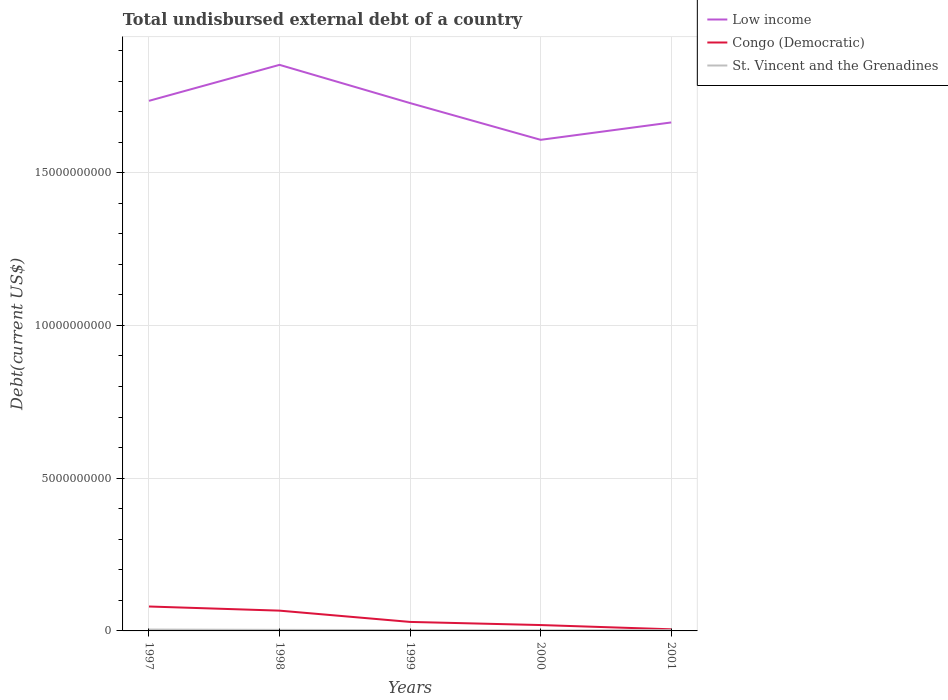Does the line corresponding to St. Vincent and the Grenadines intersect with the line corresponding to Low income?
Give a very brief answer. No. Is the number of lines equal to the number of legend labels?
Offer a terse response. Yes. Across all years, what is the maximum total undisbursed external debt in Congo (Democratic)?
Offer a very short reply. 5.33e+07. What is the total total undisbursed external debt in Congo (Democratic) in the graph?
Make the answer very short. 3.69e+08. What is the difference between the highest and the second highest total undisbursed external debt in Low income?
Offer a terse response. 2.45e+09. What is the difference between the highest and the lowest total undisbursed external debt in St. Vincent and the Grenadines?
Make the answer very short. 2. Is the total undisbursed external debt in Low income strictly greater than the total undisbursed external debt in Congo (Democratic) over the years?
Provide a succinct answer. No. How many lines are there?
Your response must be concise. 3. How many years are there in the graph?
Ensure brevity in your answer.  5. Does the graph contain grids?
Provide a succinct answer. Yes. Where does the legend appear in the graph?
Offer a terse response. Top right. How many legend labels are there?
Provide a succinct answer. 3. What is the title of the graph?
Make the answer very short. Total undisbursed external debt of a country. Does "Albania" appear as one of the legend labels in the graph?
Keep it short and to the point. No. What is the label or title of the X-axis?
Offer a very short reply. Years. What is the label or title of the Y-axis?
Provide a short and direct response. Debt(current US$). What is the Debt(current US$) of Low income in 1997?
Give a very brief answer. 1.74e+1. What is the Debt(current US$) of Congo (Democratic) in 1997?
Make the answer very short. 8.00e+08. What is the Debt(current US$) in St. Vincent and the Grenadines in 1997?
Make the answer very short. 4.47e+07. What is the Debt(current US$) in Low income in 1998?
Give a very brief answer. 1.85e+1. What is the Debt(current US$) of Congo (Democratic) in 1998?
Offer a terse response. 6.64e+08. What is the Debt(current US$) of St. Vincent and the Grenadines in 1998?
Your answer should be compact. 3.41e+07. What is the Debt(current US$) of Low income in 1999?
Your answer should be very brief. 1.73e+1. What is the Debt(current US$) of Congo (Democratic) in 1999?
Your response must be concise. 2.95e+08. What is the Debt(current US$) in St. Vincent and the Grenadines in 1999?
Provide a succinct answer. 2.66e+07. What is the Debt(current US$) of Low income in 2000?
Your answer should be very brief. 1.61e+1. What is the Debt(current US$) in Congo (Democratic) in 2000?
Offer a terse response. 1.92e+08. What is the Debt(current US$) of St. Vincent and the Grenadines in 2000?
Make the answer very short. 1.90e+07. What is the Debt(current US$) in Low income in 2001?
Make the answer very short. 1.66e+1. What is the Debt(current US$) of Congo (Democratic) in 2001?
Give a very brief answer. 5.33e+07. What is the Debt(current US$) of St. Vincent and the Grenadines in 2001?
Offer a very short reply. 2.50e+07. Across all years, what is the maximum Debt(current US$) in Low income?
Ensure brevity in your answer.  1.85e+1. Across all years, what is the maximum Debt(current US$) in Congo (Democratic)?
Your answer should be very brief. 8.00e+08. Across all years, what is the maximum Debt(current US$) of St. Vincent and the Grenadines?
Provide a succinct answer. 4.47e+07. Across all years, what is the minimum Debt(current US$) in Low income?
Give a very brief answer. 1.61e+1. Across all years, what is the minimum Debt(current US$) in Congo (Democratic)?
Your response must be concise. 5.33e+07. Across all years, what is the minimum Debt(current US$) in St. Vincent and the Grenadines?
Your response must be concise. 1.90e+07. What is the total Debt(current US$) in Low income in the graph?
Offer a very short reply. 8.59e+1. What is the total Debt(current US$) of Congo (Democratic) in the graph?
Make the answer very short. 2.00e+09. What is the total Debt(current US$) in St. Vincent and the Grenadines in the graph?
Your response must be concise. 1.49e+08. What is the difference between the Debt(current US$) in Low income in 1997 and that in 1998?
Make the answer very short. -1.18e+09. What is the difference between the Debt(current US$) in Congo (Democratic) in 1997 and that in 1998?
Your answer should be compact. 1.36e+08. What is the difference between the Debt(current US$) in St. Vincent and the Grenadines in 1997 and that in 1998?
Provide a succinct answer. 1.05e+07. What is the difference between the Debt(current US$) in Low income in 1997 and that in 1999?
Your answer should be very brief. 7.38e+07. What is the difference between the Debt(current US$) of Congo (Democratic) in 1997 and that in 1999?
Provide a short and direct response. 5.05e+08. What is the difference between the Debt(current US$) of St. Vincent and the Grenadines in 1997 and that in 1999?
Offer a terse response. 1.80e+07. What is the difference between the Debt(current US$) of Low income in 1997 and that in 2000?
Keep it short and to the point. 1.28e+09. What is the difference between the Debt(current US$) of Congo (Democratic) in 1997 and that in 2000?
Your response must be concise. 6.07e+08. What is the difference between the Debt(current US$) in St. Vincent and the Grenadines in 1997 and that in 2000?
Your answer should be compact. 2.57e+07. What is the difference between the Debt(current US$) in Low income in 1997 and that in 2001?
Make the answer very short. 7.07e+08. What is the difference between the Debt(current US$) of Congo (Democratic) in 1997 and that in 2001?
Offer a terse response. 7.46e+08. What is the difference between the Debt(current US$) in St. Vincent and the Grenadines in 1997 and that in 2001?
Your answer should be compact. 1.97e+07. What is the difference between the Debt(current US$) of Low income in 1998 and that in 1999?
Offer a terse response. 1.25e+09. What is the difference between the Debt(current US$) of Congo (Democratic) in 1998 and that in 1999?
Keep it short and to the point. 3.69e+08. What is the difference between the Debt(current US$) of St. Vincent and the Grenadines in 1998 and that in 1999?
Keep it short and to the point. 7.50e+06. What is the difference between the Debt(current US$) of Low income in 1998 and that in 2000?
Offer a very short reply. 2.45e+09. What is the difference between the Debt(current US$) of Congo (Democratic) in 1998 and that in 2000?
Ensure brevity in your answer.  4.72e+08. What is the difference between the Debt(current US$) of St. Vincent and the Grenadines in 1998 and that in 2000?
Offer a very short reply. 1.52e+07. What is the difference between the Debt(current US$) of Low income in 1998 and that in 2001?
Make the answer very short. 1.89e+09. What is the difference between the Debt(current US$) of Congo (Democratic) in 1998 and that in 2001?
Your response must be concise. 6.10e+08. What is the difference between the Debt(current US$) in St. Vincent and the Grenadines in 1998 and that in 2001?
Offer a very short reply. 9.16e+06. What is the difference between the Debt(current US$) of Low income in 1999 and that in 2000?
Provide a short and direct response. 1.20e+09. What is the difference between the Debt(current US$) of Congo (Democratic) in 1999 and that in 2000?
Provide a short and direct response. 1.03e+08. What is the difference between the Debt(current US$) in St. Vincent and the Grenadines in 1999 and that in 2000?
Your answer should be compact. 7.69e+06. What is the difference between the Debt(current US$) of Low income in 1999 and that in 2001?
Offer a terse response. 6.34e+08. What is the difference between the Debt(current US$) in Congo (Democratic) in 1999 and that in 2001?
Give a very brief answer. 2.41e+08. What is the difference between the Debt(current US$) in St. Vincent and the Grenadines in 1999 and that in 2001?
Your answer should be very brief. 1.66e+06. What is the difference between the Debt(current US$) of Low income in 2000 and that in 2001?
Give a very brief answer. -5.69e+08. What is the difference between the Debt(current US$) in Congo (Democratic) in 2000 and that in 2001?
Your answer should be compact. 1.39e+08. What is the difference between the Debt(current US$) in St. Vincent and the Grenadines in 2000 and that in 2001?
Make the answer very short. -6.02e+06. What is the difference between the Debt(current US$) in Low income in 1997 and the Debt(current US$) in Congo (Democratic) in 1998?
Your answer should be compact. 1.67e+1. What is the difference between the Debt(current US$) of Low income in 1997 and the Debt(current US$) of St. Vincent and the Grenadines in 1998?
Ensure brevity in your answer.  1.73e+1. What is the difference between the Debt(current US$) in Congo (Democratic) in 1997 and the Debt(current US$) in St. Vincent and the Grenadines in 1998?
Offer a very short reply. 7.65e+08. What is the difference between the Debt(current US$) in Low income in 1997 and the Debt(current US$) in Congo (Democratic) in 1999?
Your answer should be very brief. 1.71e+1. What is the difference between the Debt(current US$) in Low income in 1997 and the Debt(current US$) in St. Vincent and the Grenadines in 1999?
Offer a terse response. 1.73e+1. What is the difference between the Debt(current US$) in Congo (Democratic) in 1997 and the Debt(current US$) in St. Vincent and the Grenadines in 1999?
Provide a short and direct response. 7.73e+08. What is the difference between the Debt(current US$) of Low income in 1997 and the Debt(current US$) of Congo (Democratic) in 2000?
Make the answer very short. 1.72e+1. What is the difference between the Debt(current US$) of Low income in 1997 and the Debt(current US$) of St. Vincent and the Grenadines in 2000?
Provide a succinct answer. 1.73e+1. What is the difference between the Debt(current US$) of Congo (Democratic) in 1997 and the Debt(current US$) of St. Vincent and the Grenadines in 2000?
Keep it short and to the point. 7.81e+08. What is the difference between the Debt(current US$) in Low income in 1997 and the Debt(current US$) in Congo (Democratic) in 2001?
Your answer should be very brief. 1.73e+1. What is the difference between the Debt(current US$) of Low income in 1997 and the Debt(current US$) of St. Vincent and the Grenadines in 2001?
Provide a succinct answer. 1.73e+1. What is the difference between the Debt(current US$) of Congo (Democratic) in 1997 and the Debt(current US$) of St. Vincent and the Grenadines in 2001?
Offer a very short reply. 7.75e+08. What is the difference between the Debt(current US$) of Low income in 1998 and the Debt(current US$) of Congo (Democratic) in 1999?
Your answer should be compact. 1.82e+1. What is the difference between the Debt(current US$) of Low income in 1998 and the Debt(current US$) of St. Vincent and the Grenadines in 1999?
Provide a succinct answer. 1.85e+1. What is the difference between the Debt(current US$) of Congo (Democratic) in 1998 and the Debt(current US$) of St. Vincent and the Grenadines in 1999?
Ensure brevity in your answer.  6.37e+08. What is the difference between the Debt(current US$) in Low income in 1998 and the Debt(current US$) in Congo (Democratic) in 2000?
Offer a terse response. 1.83e+1. What is the difference between the Debt(current US$) in Low income in 1998 and the Debt(current US$) in St. Vincent and the Grenadines in 2000?
Your answer should be very brief. 1.85e+1. What is the difference between the Debt(current US$) of Congo (Democratic) in 1998 and the Debt(current US$) of St. Vincent and the Grenadines in 2000?
Offer a very short reply. 6.45e+08. What is the difference between the Debt(current US$) of Low income in 1998 and the Debt(current US$) of Congo (Democratic) in 2001?
Provide a succinct answer. 1.85e+1. What is the difference between the Debt(current US$) of Low income in 1998 and the Debt(current US$) of St. Vincent and the Grenadines in 2001?
Your answer should be compact. 1.85e+1. What is the difference between the Debt(current US$) in Congo (Democratic) in 1998 and the Debt(current US$) in St. Vincent and the Grenadines in 2001?
Keep it short and to the point. 6.39e+08. What is the difference between the Debt(current US$) of Low income in 1999 and the Debt(current US$) of Congo (Democratic) in 2000?
Make the answer very short. 1.71e+1. What is the difference between the Debt(current US$) of Low income in 1999 and the Debt(current US$) of St. Vincent and the Grenadines in 2000?
Give a very brief answer. 1.73e+1. What is the difference between the Debt(current US$) in Congo (Democratic) in 1999 and the Debt(current US$) in St. Vincent and the Grenadines in 2000?
Ensure brevity in your answer.  2.76e+08. What is the difference between the Debt(current US$) of Low income in 1999 and the Debt(current US$) of Congo (Democratic) in 2001?
Give a very brief answer. 1.72e+1. What is the difference between the Debt(current US$) in Low income in 1999 and the Debt(current US$) in St. Vincent and the Grenadines in 2001?
Your answer should be compact. 1.73e+1. What is the difference between the Debt(current US$) in Congo (Democratic) in 1999 and the Debt(current US$) in St. Vincent and the Grenadines in 2001?
Your response must be concise. 2.70e+08. What is the difference between the Debt(current US$) in Low income in 2000 and the Debt(current US$) in Congo (Democratic) in 2001?
Your answer should be compact. 1.60e+1. What is the difference between the Debt(current US$) of Low income in 2000 and the Debt(current US$) of St. Vincent and the Grenadines in 2001?
Ensure brevity in your answer.  1.60e+1. What is the difference between the Debt(current US$) of Congo (Democratic) in 2000 and the Debt(current US$) of St. Vincent and the Grenadines in 2001?
Your response must be concise. 1.67e+08. What is the average Debt(current US$) in Low income per year?
Provide a succinct answer. 1.72e+1. What is the average Debt(current US$) in Congo (Democratic) per year?
Keep it short and to the point. 4.01e+08. What is the average Debt(current US$) in St. Vincent and the Grenadines per year?
Offer a terse response. 2.99e+07. In the year 1997, what is the difference between the Debt(current US$) of Low income and Debt(current US$) of Congo (Democratic)?
Make the answer very short. 1.66e+1. In the year 1997, what is the difference between the Debt(current US$) of Low income and Debt(current US$) of St. Vincent and the Grenadines?
Provide a short and direct response. 1.73e+1. In the year 1997, what is the difference between the Debt(current US$) of Congo (Democratic) and Debt(current US$) of St. Vincent and the Grenadines?
Your response must be concise. 7.55e+08. In the year 1998, what is the difference between the Debt(current US$) in Low income and Debt(current US$) in Congo (Democratic)?
Your response must be concise. 1.79e+1. In the year 1998, what is the difference between the Debt(current US$) of Low income and Debt(current US$) of St. Vincent and the Grenadines?
Give a very brief answer. 1.85e+1. In the year 1998, what is the difference between the Debt(current US$) of Congo (Democratic) and Debt(current US$) of St. Vincent and the Grenadines?
Provide a short and direct response. 6.30e+08. In the year 1999, what is the difference between the Debt(current US$) in Low income and Debt(current US$) in Congo (Democratic)?
Keep it short and to the point. 1.70e+1. In the year 1999, what is the difference between the Debt(current US$) of Low income and Debt(current US$) of St. Vincent and the Grenadines?
Offer a very short reply. 1.73e+1. In the year 1999, what is the difference between the Debt(current US$) of Congo (Democratic) and Debt(current US$) of St. Vincent and the Grenadines?
Offer a very short reply. 2.68e+08. In the year 2000, what is the difference between the Debt(current US$) of Low income and Debt(current US$) of Congo (Democratic)?
Your response must be concise. 1.59e+1. In the year 2000, what is the difference between the Debt(current US$) in Low income and Debt(current US$) in St. Vincent and the Grenadines?
Keep it short and to the point. 1.61e+1. In the year 2000, what is the difference between the Debt(current US$) of Congo (Democratic) and Debt(current US$) of St. Vincent and the Grenadines?
Keep it short and to the point. 1.73e+08. In the year 2001, what is the difference between the Debt(current US$) of Low income and Debt(current US$) of Congo (Democratic)?
Your response must be concise. 1.66e+1. In the year 2001, what is the difference between the Debt(current US$) in Low income and Debt(current US$) in St. Vincent and the Grenadines?
Provide a succinct answer. 1.66e+1. In the year 2001, what is the difference between the Debt(current US$) in Congo (Democratic) and Debt(current US$) in St. Vincent and the Grenadines?
Keep it short and to the point. 2.83e+07. What is the ratio of the Debt(current US$) in Low income in 1997 to that in 1998?
Your response must be concise. 0.94. What is the ratio of the Debt(current US$) of Congo (Democratic) in 1997 to that in 1998?
Make the answer very short. 1.2. What is the ratio of the Debt(current US$) in St. Vincent and the Grenadines in 1997 to that in 1998?
Provide a succinct answer. 1.31. What is the ratio of the Debt(current US$) in Low income in 1997 to that in 1999?
Keep it short and to the point. 1. What is the ratio of the Debt(current US$) in Congo (Democratic) in 1997 to that in 1999?
Keep it short and to the point. 2.71. What is the ratio of the Debt(current US$) in St. Vincent and the Grenadines in 1997 to that in 1999?
Offer a terse response. 1.68. What is the ratio of the Debt(current US$) of Low income in 1997 to that in 2000?
Give a very brief answer. 1.08. What is the ratio of the Debt(current US$) in Congo (Democratic) in 1997 to that in 2000?
Your answer should be very brief. 4.16. What is the ratio of the Debt(current US$) of St. Vincent and the Grenadines in 1997 to that in 2000?
Your answer should be very brief. 2.36. What is the ratio of the Debt(current US$) of Low income in 1997 to that in 2001?
Give a very brief answer. 1.04. What is the ratio of the Debt(current US$) of Congo (Democratic) in 1997 to that in 2001?
Your answer should be very brief. 15. What is the ratio of the Debt(current US$) of St. Vincent and the Grenadines in 1997 to that in 2001?
Provide a short and direct response. 1.79. What is the ratio of the Debt(current US$) of Low income in 1998 to that in 1999?
Your answer should be very brief. 1.07. What is the ratio of the Debt(current US$) in Congo (Democratic) in 1998 to that in 1999?
Make the answer very short. 2.25. What is the ratio of the Debt(current US$) in St. Vincent and the Grenadines in 1998 to that in 1999?
Make the answer very short. 1.28. What is the ratio of the Debt(current US$) in Low income in 1998 to that in 2000?
Offer a very short reply. 1.15. What is the ratio of the Debt(current US$) of Congo (Democratic) in 1998 to that in 2000?
Your response must be concise. 3.46. What is the ratio of the Debt(current US$) of St. Vincent and the Grenadines in 1998 to that in 2000?
Give a very brief answer. 1.8. What is the ratio of the Debt(current US$) in Low income in 1998 to that in 2001?
Give a very brief answer. 1.11. What is the ratio of the Debt(current US$) in Congo (Democratic) in 1998 to that in 2001?
Offer a very short reply. 12.45. What is the ratio of the Debt(current US$) in St. Vincent and the Grenadines in 1998 to that in 2001?
Ensure brevity in your answer.  1.37. What is the ratio of the Debt(current US$) of Low income in 1999 to that in 2000?
Make the answer very short. 1.07. What is the ratio of the Debt(current US$) of Congo (Democratic) in 1999 to that in 2000?
Offer a very short reply. 1.53. What is the ratio of the Debt(current US$) in St. Vincent and the Grenadines in 1999 to that in 2000?
Keep it short and to the point. 1.41. What is the ratio of the Debt(current US$) in Low income in 1999 to that in 2001?
Provide a short and direct response. 1.04. What is the ratio of the Debt(current US$) of Congo (Democratic) in 1999 to that in 2001?
Provide a succinct answer. 5.53. What is the ratio of the Debt(current US$) of St. Vincent and the Grenadines in 1999 to that in 2001?
Ensure brevity in your answer.  1.07. What is the ratio of the Debt(current US$) in Low income in 2000 to that in 2001?
Offer a terse response. 0.97. What is the ratio of the Debt(current US$) of Congo (Democratic) in 2000 to that in 2001?
Your answer should be very brief. 3.6. What is the ratio of the Debt(current US$) of St. Vincent and the Grenadines in 2000 to that in 2001?
Your answer should be compact. 0.76. What is the difference between the highest and the second highest Debt(current US$) of Low income?
Your response must be concise. 1.18e+09. What is the difference between the highest and the second highest Debt(current US$) in Congo (Democratic)?
Provide a succinct answer. 1.36e+08. What is the difference between the highest and the second highest Debt(current US$) of St. Vincent and the Grenadines?
Your answer should be compact. 1.05e+07. What is the difference between the highest and the lowest Debt(current US$) in Low income?
Your answer should be compact. 2.45e+09. What is the difference between the highest and the lowest Debt(current US$) of Congo (Democratic)?
Your response must be concise. 7.46e+08. What is the difference between the highest and the lowest Debt(current US$) of St. Vincent and the Grenadines?
Offer a terse response. 2.57e+07. 